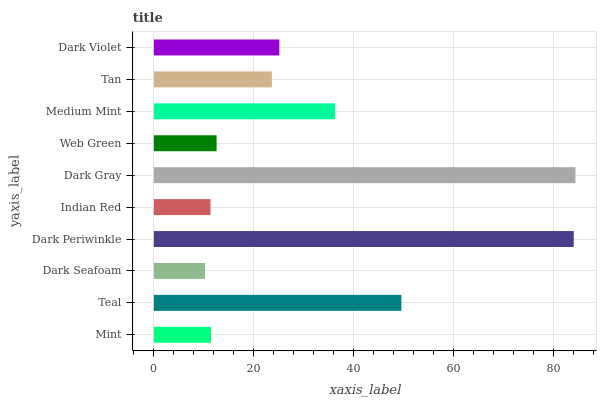Is Dark Seafoam the minimum?
Answer yes or no. Yes. Is Dark Gray the maximum?
Answer yes or no. Yes. Is Teal the minimum?
Answer yes or no. No. Is Teal the maximum?
Answer yes or no. No. Is Teal greater than Mint?
Answer yes or no. Yes. Is Mint less than Teal?
Answer yes or no. Yes. Is Mint greater than Teal?
Answer yes or no. No. Is Teal less than Mint?
Answer yes or no. No. Is Dark Violet the high median?
Answer yes or no. Yes. Is Tan the low median?
Answer yes or no. Yes. Is Dark Gray the high median?
Answer yes or no. No. Is Web Green the low median?
Answer yes or no. No. 